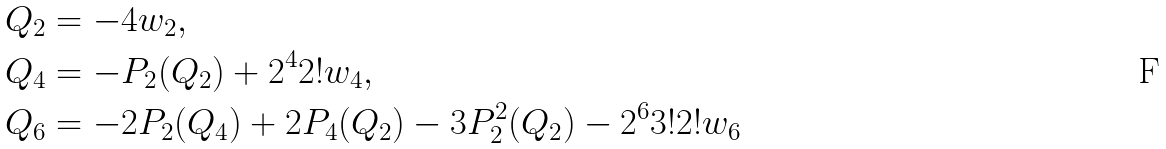Convert formula to latex. <formula><loc_0><loc_0><loc_500><loc_500>Q _ { 2 } & = - 4 w _ { 2 } , \\ Q _ { 4 } & = - P _ { 2 } ( Q _ { 2 } ) + 2 ^ { 4 } 2 ! w _ { 4 } , \\ Q _ { 6 } & = - 2 P _ { 2 } ( Q _ { 4 } ) + 2 P _ { 4 } ( Q _ { 2 } ) - 3 P _ { 2 } ^ { 2 } ( Q _ { 2 } ) - 2 ^ { 6 } 3 ! 2 ! w _ { 6 }</formula> 